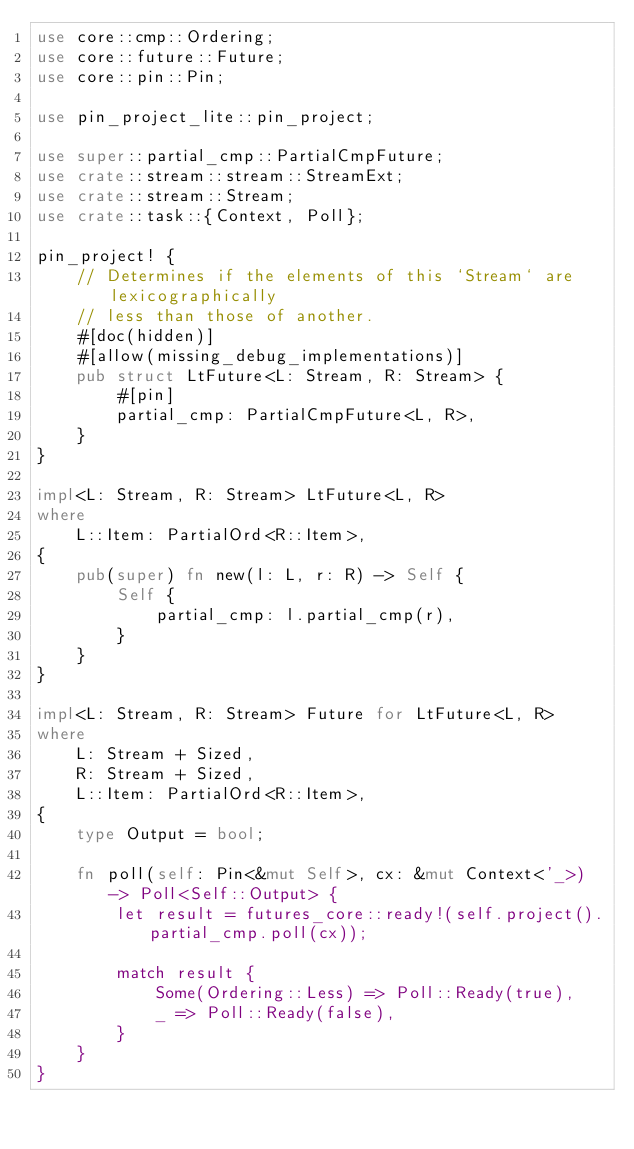<code> <loc_0><loc_0><loc_500><loc_500><_Rust_>use core::cmp::Ordering;
use core::future::Future;
use core::pin::Pin;

use pin_project_lite::pin_project;

use super::partial_cmp::PartialCmpFuture;
use crate::stream::stream::StreamExt;
use crate::stream::Stream;
use crate::task::{Context, Poll};

pin_project! {
    // Determines if the elements of this `Stream` are lexicographically
    // less than those of another.
    #[doc(hidden)]
    #[allow(missing_debug_implementations)]
    pub struct LtFuture<L: Stream, R: Stream> {
        #[pin]
        partial_cmp: PartialCmpFuture<L, R>,
    }
}

impl<L: Stream, R: Stream> LtFuture<L, R>
where
    L::Item: PartialOrd<R::Item>,
{
    pub(super) fn new(l: L, r: R) -> Self {
        Self {
            partial_cmp: l.partial_cmp(r),
        }
    }
}

impl<L: Stream, R: Stream> Future for LtFuture<L, R>
where
    L: Stream + Sized,
    R: Stream + Sized,
    L::Item: PartialOrd<R::Item>,
{
    type Output = bool;

    fn poll(self: Pin<&mut Self>, cx: &mut Context<'_>) -> Poll<Self::Output> {
        let result = futures_core::ready!(self.project().partial_cmp.poll(cx));

        match result {
            Some(Ordering::Less) => Poll::Ready(true),
            _ => Poll::Ready(false),
        }
    }
}
</code> 